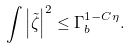<formula> <loc_0><loc_0><loc_500><loc_500>\int \left | \tilde { \zeta } \right | ^ { 2 } \leq \Gamma _ { b } ^ { 1 - C \eta } .</formula> 